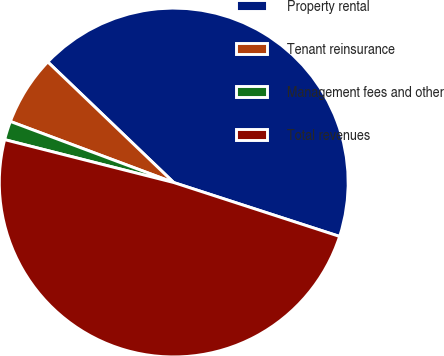Convert chart. <chart><loc_0><loc_0><loc_500><loc_500><pie_chart><fcel>Property rental<fcel>Tenant reinsurance<fcel>Management fees and other<fcel>Total revenues<nl><fcel>42.84%<fcel>6.46%<fcel>1.74%<fcel>48.95%<nl></chart> 